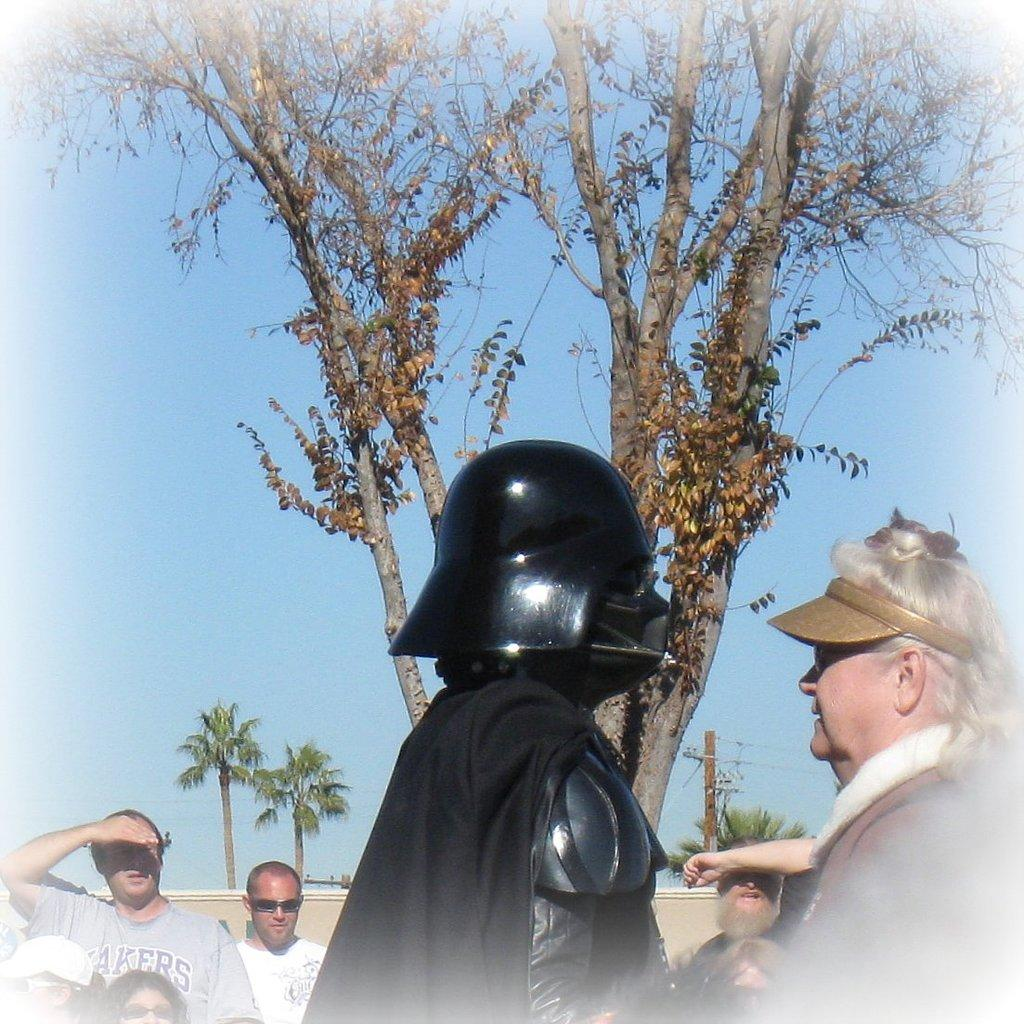How many people are in the image? There are people in the image, but the exact number is not specified. What type of natural elements can be seen in the image? There are trees in the image. What object is present in the image that might be used for support or signage? There is a pole in the image. What is unique about one of the people in the image? There is a person wearing a costume in the middle of the image. What book is the person reading in the image? There is no person reading a book in the image. How many cars are visible in the image? There are no cars visible in the image. 